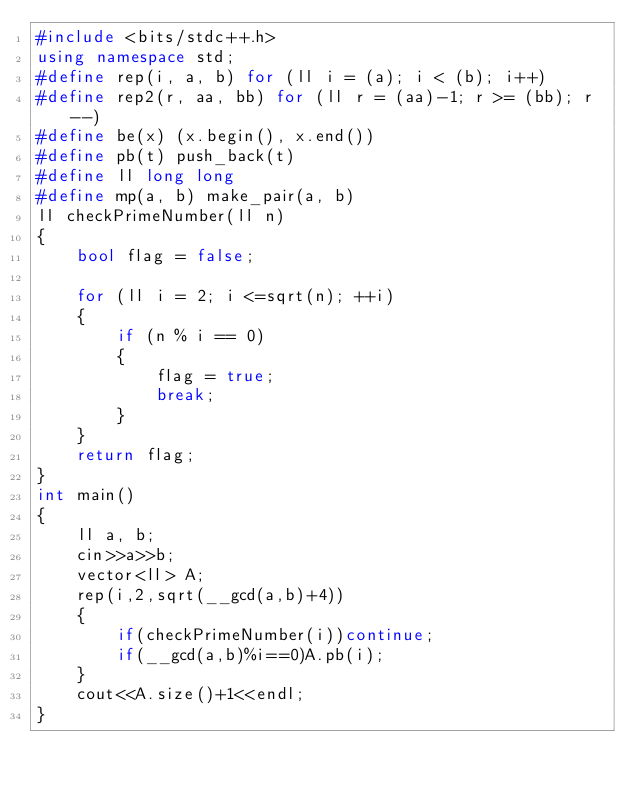Convert code to text. <code><loc_0><loc_0><loc_500><loc_500><_C++_>#include <bits/stdc++.h>
using namespace std;
#define rep(i, a, b) for (ll i = (a); i < (b); i++)
#define rep2(r, aa, bb) for (ll r = (aa)-1; r >= (bb); r--)
#define be(x) (x.begin(), x.end())
#define pb(t) push_back(t)
#define ll long long
#define mp(a, b) make_pair(a, b)
ll checkPrimeNumber(ll n)
{
    bool flag = false;

    for (ll i = 2; i <=sqrt(n); ++i)
    {
        if (n % i == 0)
        {
            flag = true;
            break;
        }
    }
    return flag;
}
int main()
{
    ll a, b;
    cin>>a>>b;
    vector<ll> A;
    rep(i,2,sqrt(__gcd(a,b)+4))
    {
        if(checkPrimeNumber(i))continue;
        if(__gcd(a,b)%i==0)A.pb(i);
    }
    cout<<A.size()+1<<endl;
}</code> 